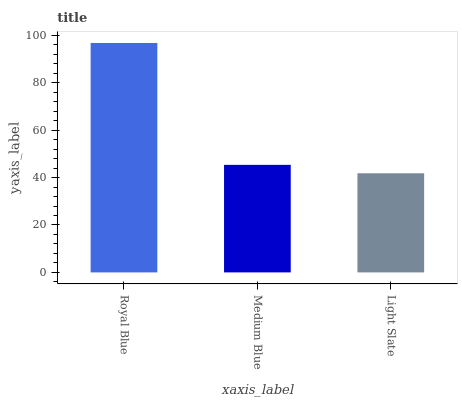Is Light Slate the minimum?
Answer yes or no. Yes. Is Royal Blue the maximum?
Answer yes or no. Yes. Is Medium Blue the minimum?
Answer yes or no. No. Is Medium Blue the maximum?
Answer yes or no. No. Is Royal Blue greater than Medium Blue?
Answer yes or no. Yes. Is Medium Blue less than Royal Blue?
Answer yes or no. Yes. Is Medium Blue greater than Royal Blue?
Answer yes or no. No. Is Royal Blue less than Medium Blue?
Answer yes or no. No. Is Medium Blue the high median?
Answer yes or no. Yes. Is Medium Blue the low median?
Answer yes or no. Yes. Is Light Slate the high median?
Answer yes or no. No. Is Light Slate the low median?
Answer yes or no. No. 